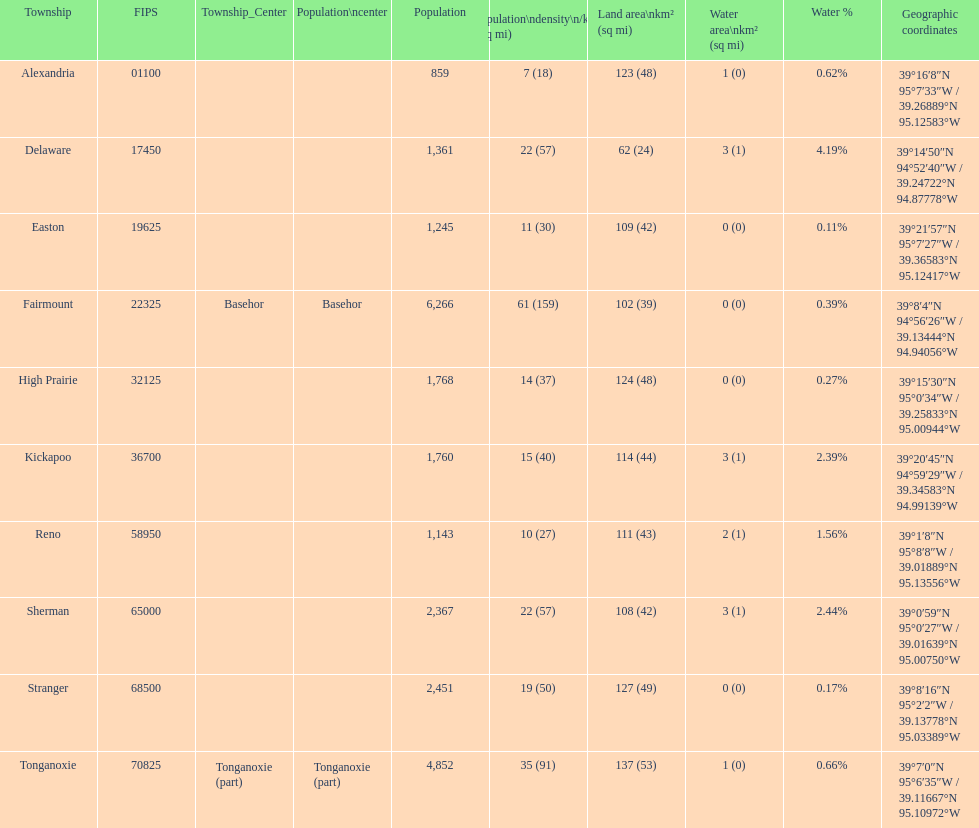How many townships have populations over 2,000? 4. 